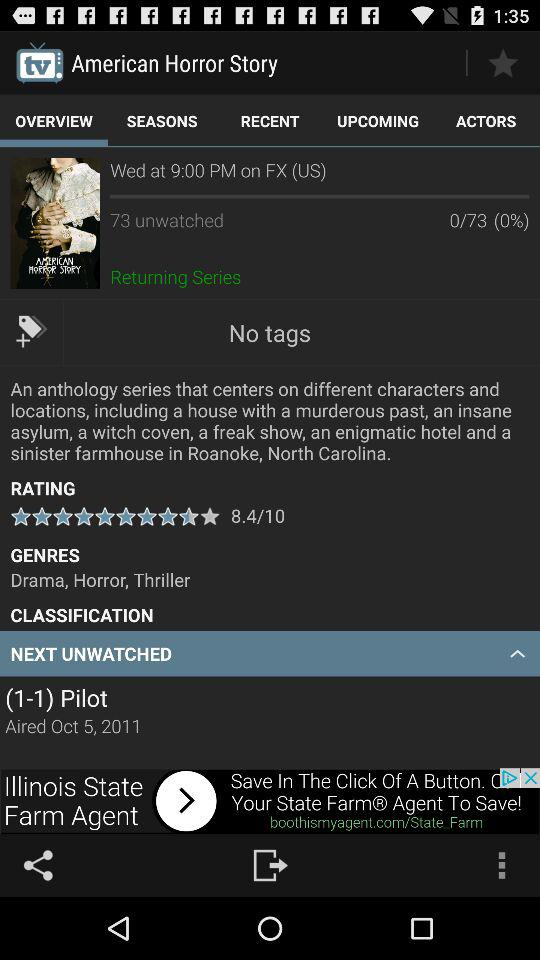What is the name of the series? The name of the series is "American Horror Story". 